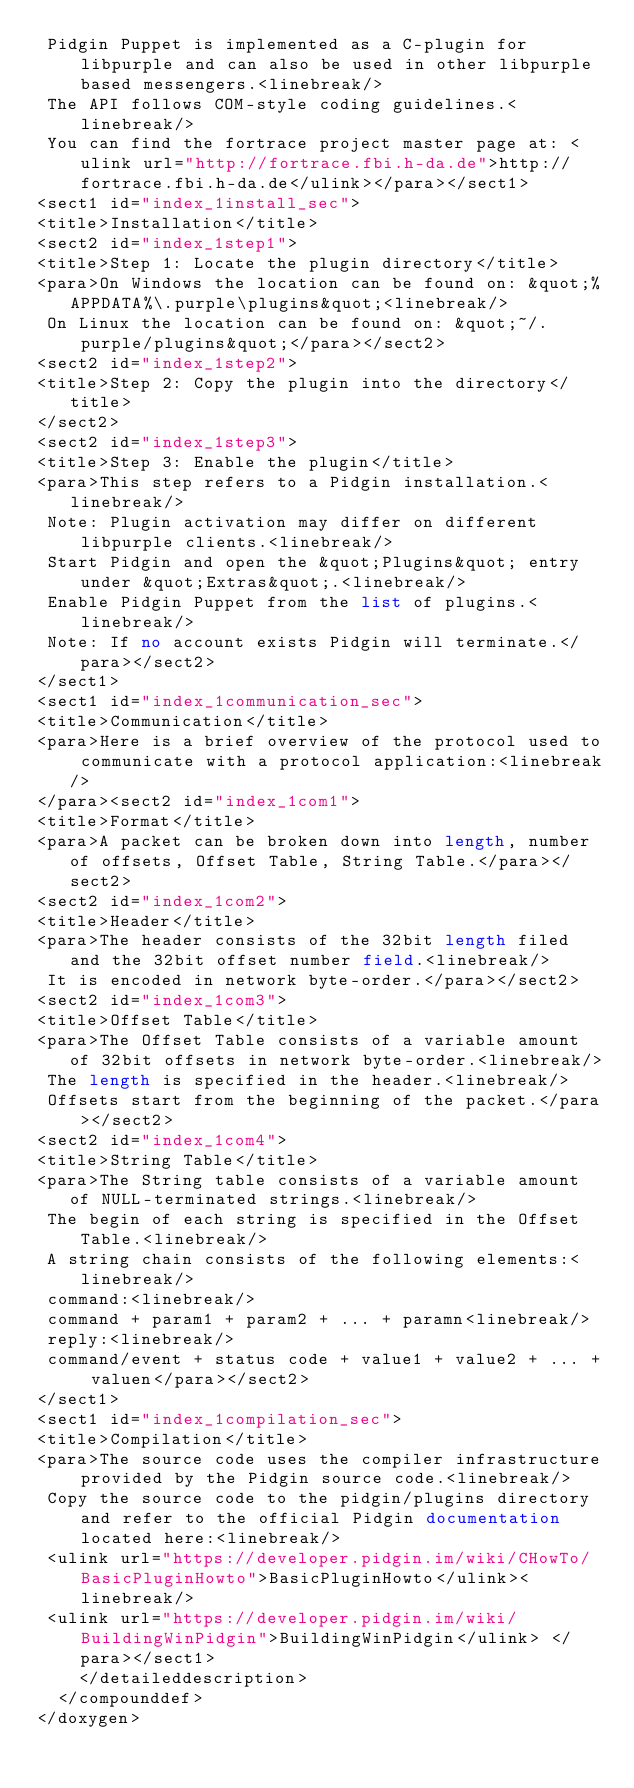<code> <loc_0><loc_0><loc_500><loc_500><_XML_> Pidgin Puppet is implemented as a C-plugin for libpurple and can also be used in other libpurple based messengers.<linebreak/>
 The API follows COM-style coding guidelines.<linebreak/>
 You can find the fortrace project master page at: <ulink url="http://fortrace.fbi.h-da.de">http://fortrace.fbi.h-da.de</ulink></para></sect1>
<sect1 id="index_1install_sec">
<title>Installation</title>
<sect2 id="index_1step1">
<title>Step 1: Locate the plugin directory</title>
<para>On Windows the location can be found on: &quot;%APPDATA%\.purple\plugins&quot;<linebreak/>
 On Linux the location can be found on: &quot;~/.purple/plugins&quot;</para></sect2>
<sect2 id="index_1step2">
<title>Step 2: Copy the plugin into the directory</title>
</sect2>
<sect2 id="index_1step3">
<title>Step 3: Enable the plugin</title>
<para>This step refers to a Pidgin installation.<linebreak/>
 Note: Plugin activation may differ on different libpurple clients.<linebreak/>
 Start Pidgin and open the &quot;Plugins&quot; entry under &quot;Extras&quot;.<linebreak/>
 Enable Pidgin Puppet from the list of plugins.<linebreak/>
 Note: If no account exists Pidgin will terminate.</para></sect2>
</sect1>
<sect1 id="index_1communication_sec">
<title>Communication</title>
<para>Here is a brief overview of the protocol used to communicate with a protocol application:<linebreak/>
</para><sect2 id="index_1com1">
<title>Format</title>
<para>A packet can be broken down into length, number of offsets, Offset Table, String Table.</para></sect2>
<sect2 id="index_1com2">
<title>Header</title>
<para>The header consists of the 32bit length filed and the 32bit offset number field.<linebreak/>
 It is encoded in network byte-order.</para></sect2>
<sect2 id="index_1com3">
<title>Offset Table</title>
<para>The Offset Table consists of a variable amount of 32bit offsets in network byte-order.<linebreak/>
 The length is specified in the header.<linebreak/>
 Offsets start from the beginning of the packet.</para></sect2>
<sect2 id="index_1com4">
<title>String Table</title>
<para>The String table consists of a variable amount of NULL-terminated strings.<linebreak/>
 The begin of each string is specified in the Offset Table.<linebreak/>
 A string chain consists of the following elements:<linebreak/>
 command:<linebreak/>
 command + param1 + param2 + ... + paramn<linebreak/>
 reply:<linebreak/>
 command/event + status code + value1 + value2 + ... + valuen</para></sect2>
</sect1>
<sect1 id="index_1compilation_sec">
<title>Compilation</title>
<para>The source code uses the compiler infrastructure provided by the Pidgin source code.<linebreak/>
 Copy the source code to the pidgin/plugins directory and refer to the official Pidgin documentation located here:<linebreak/>
 <ulink url="https://developer.pidgin.im/wiki/CHowTo/BasicPluginHowto">BasicPluginHowto</ulink><linebreak/>
 <ulink url="https://developer.pidgin.im/wiki/BuildingWinPidgin">BuildingWinPidgin</ulink> </para></sect1>
    </detaileddescription>
  </compounddef>
</doxygen>
</code> 